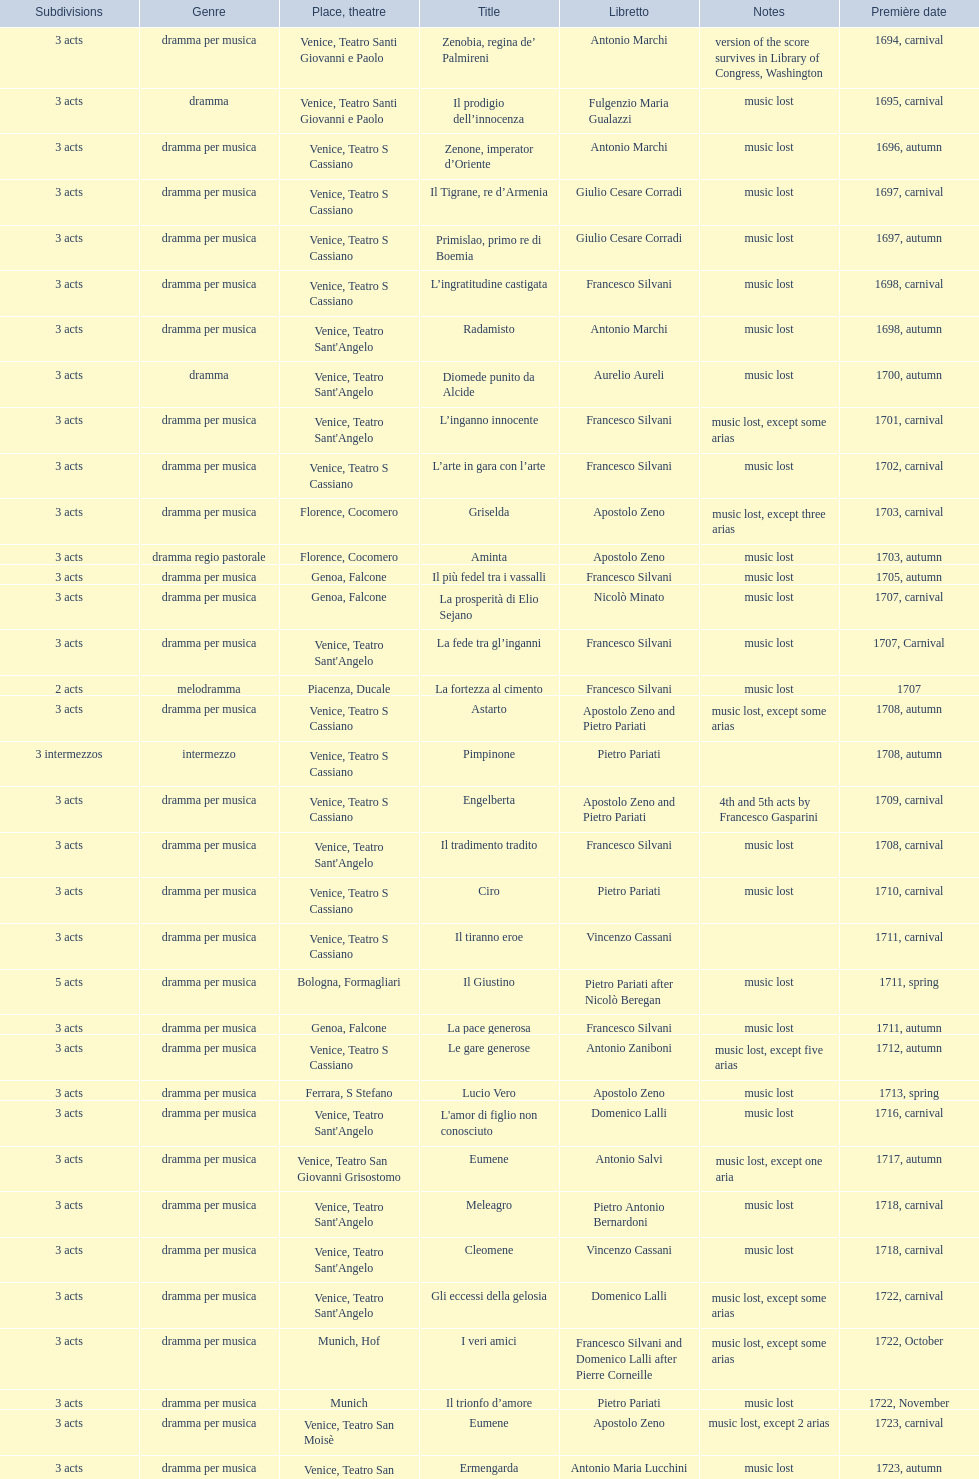L'inganno innocente premiered in 1701. what was the previous title released? Diomede punito da Alcide. 